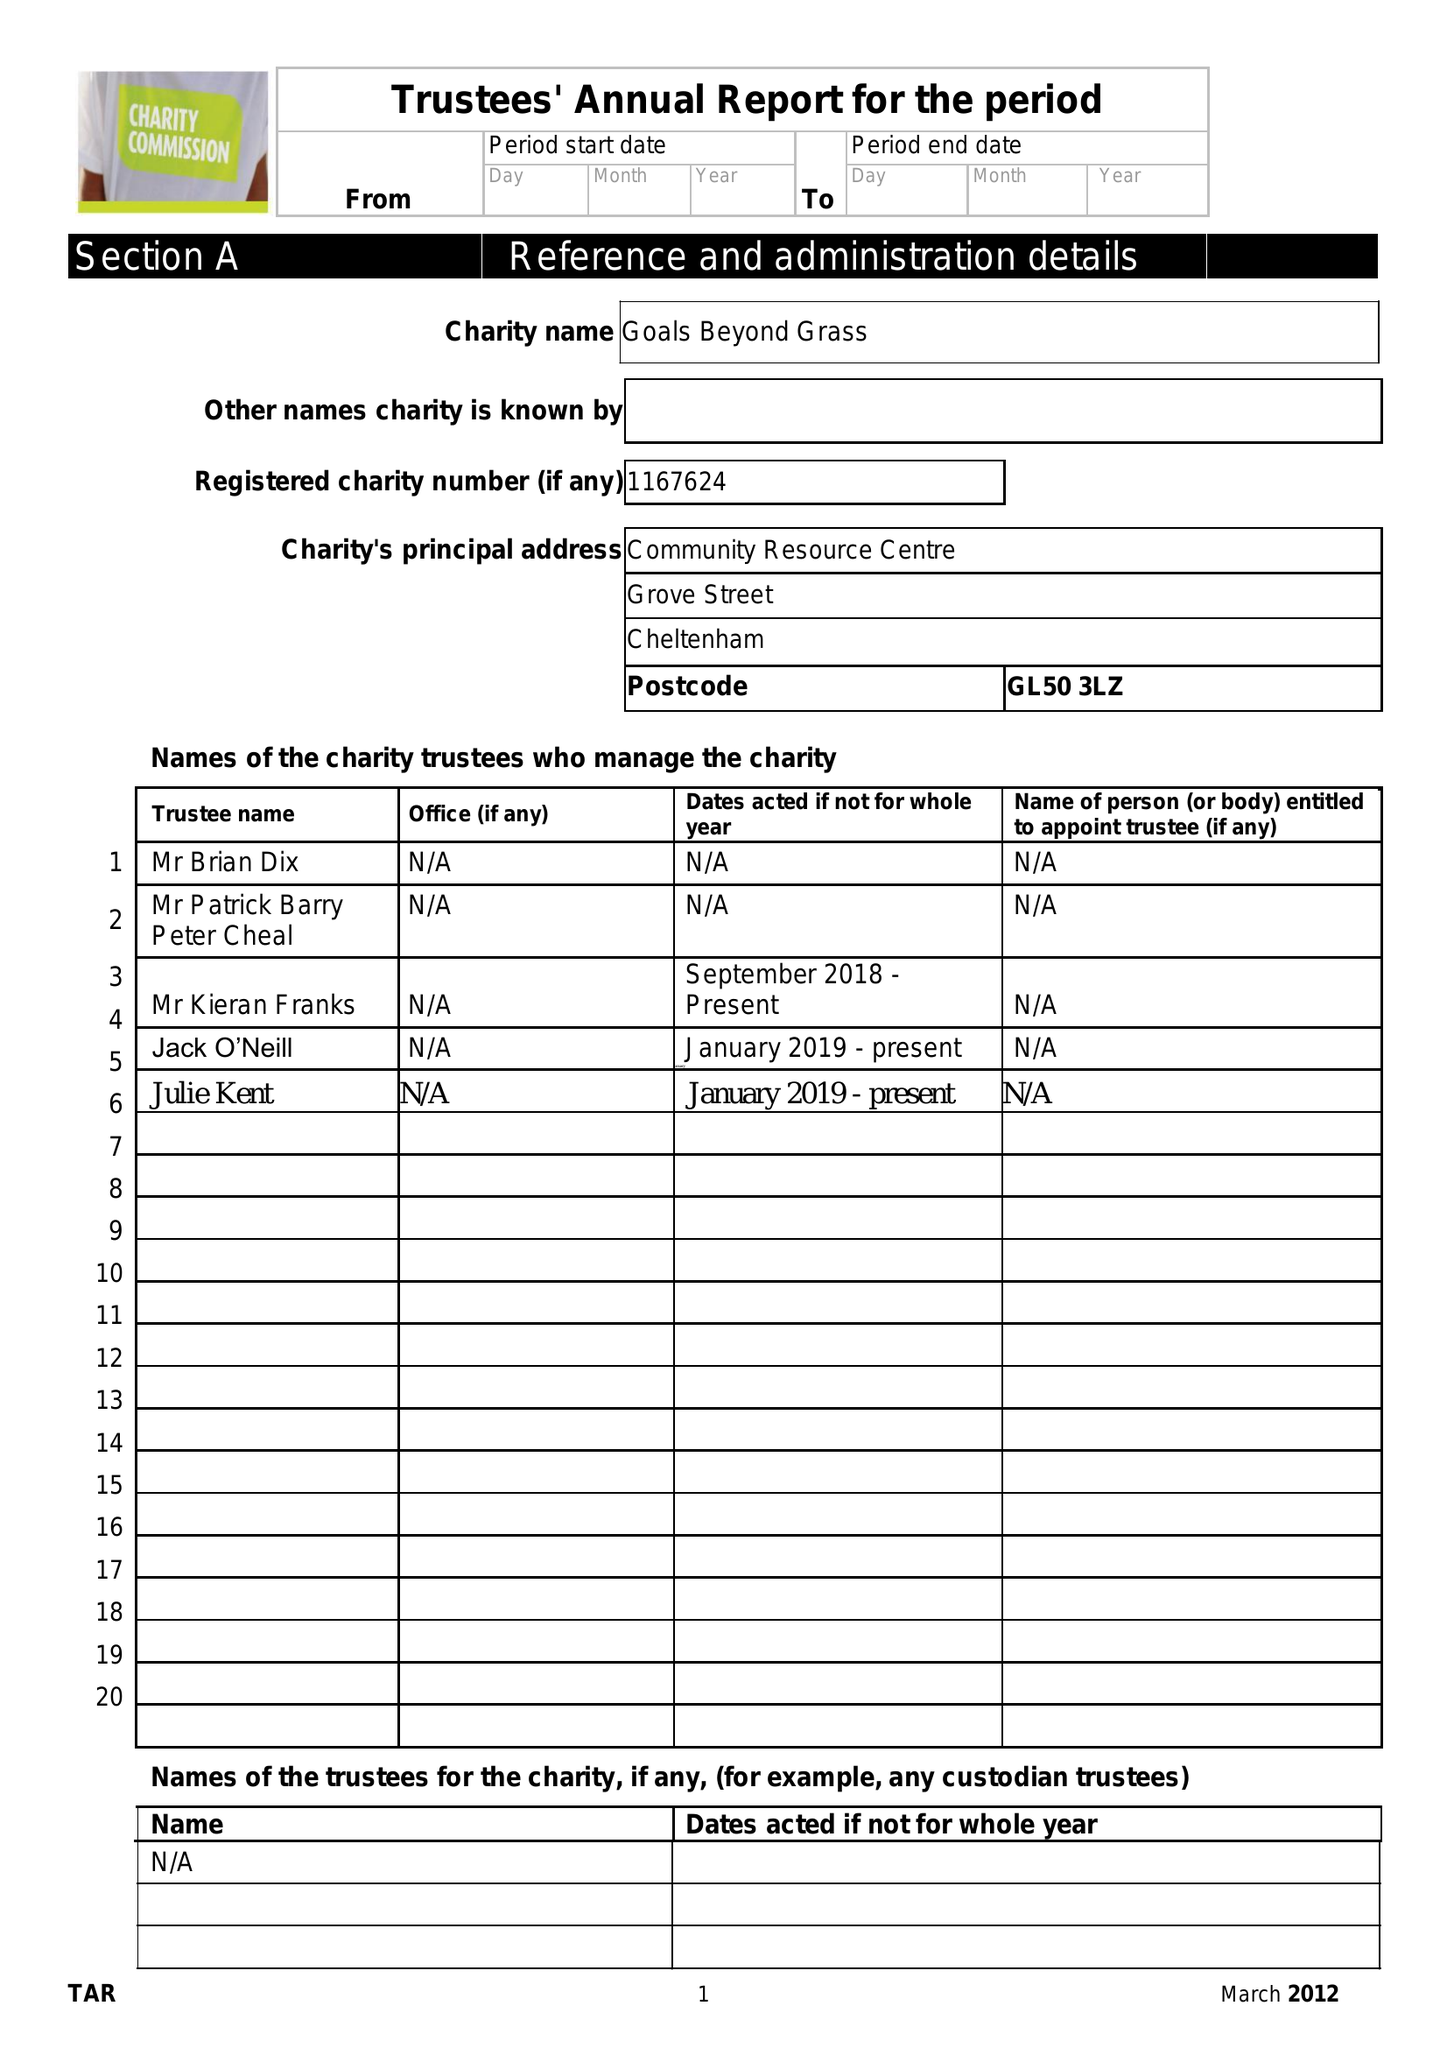What is the value for the charity_name?
Answer the question using a single word or phrase. Goals Beyond Grass 